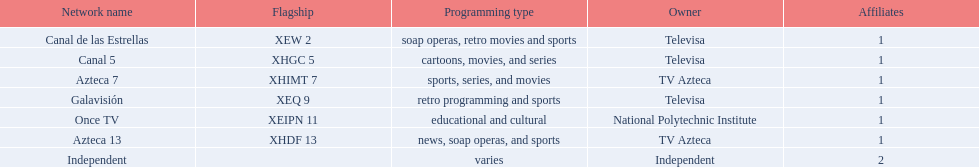What tv channels are available in morelos? Canal de las Estrellas, Canal 5, Azteca 7, Galavisión, Once TV, Azteca 13, Independent. Among them, which one is owned by the national polytechnic institute? Once TV. 